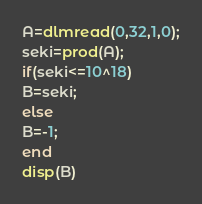<code> <loc_0><loc_0><loc_500><loc_500><_Octave_>A=dlmread(0,32,1,0);
seki=prod(A);
if(seki<=10^18)
B=seki;
else
B=-1;
end
disp(B)
</code> 